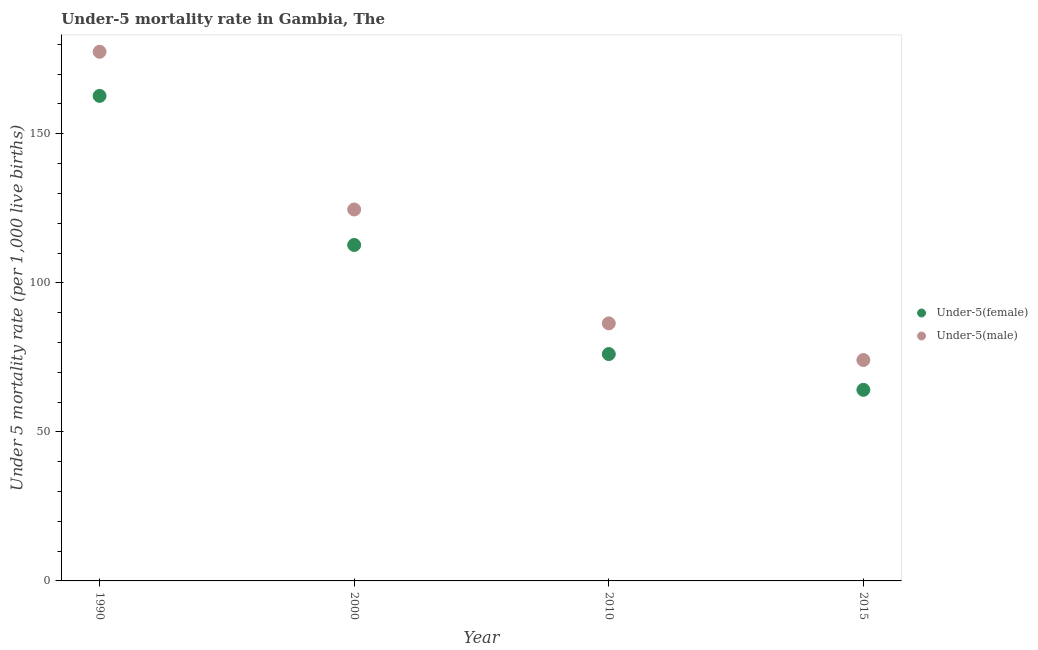Is the number of dotlines equal to the number of legend labels?
Your answer should be very brief. Yes. What is the under-5 male mortality rate in 2010?
Offer a very short reply. 86.4. Across all years, what is the maximum under-5 female mortality rate?
Offer a very short reply. 162.7. Across all years, what is the minimum under-5 male mortality rate?
Make the answer very short. 74.1. In which year was the under-5 female mortality rate maximum?
Provide a short and direct response. 1990. In which year was the under-5 male mortality rate minimum?
Give a very brief answer. 2015. What is the total under-5 female mortality rate in the graph?
Your answer should be compact. 415.6. What is the difference between the under-5 female mortality rate in 1990 and that in 2015?
Provide a short and direct response. 98.6. What is the average under-5 male mortality rate per year?
Offer a very short reply. 115.65. In the year 2010, what is the difference between the under-5 male mortality rate and under-5 female mortality rate?
Your response must be concise. 10.3. In how many years, is the under-5 male mortality rate greater than 30?
Your answer should be very brief. 4. What is the ratio of the under-5 female mortality rate in 2010 to that in 2015?
Your response must be concise. 1.19. Is the under-5 female mortality rate in 1990 less than that in 2010?
Make the answer very short. No. What is the difference between the highest and the second highest under-5 male mortality rate?
Offer a terse response. 52.9. What is the difference between the highest and the lowest under-5 male mortality rate?
Give a very brief answer. 103.4. In how many years, is the under-5 male mortality rate greater than the average under-5 male mortality rate taken over all years?
Provide a succinct answer. 2. Is the sum of the under-5 female mortality rate in 1990 and 2010 greater than the maximum under-5 male mortality rate across all years?
Your answer should be compact. Yes. Does the under-5 female mortality rate monotonically increase over the years?
Keep it short and to the point. No. How many dotlines are there?
Your answer should be very brief. 2. How many years are there in the graph?
Make the answer very short. 4. What is the difference between two consecutive major ticks on the Y-axis?
Offer a terse response. 50. Are the values on the major ticks of Y-axis written in scientific E-notation?
Offer a terse response. No. Does the graph contain any zero values?
Offer a terse response. No. How are the legend labels stacked?
Offer a terse response. Vertical. What is the title of the graph?
Offer a terse response. Under-5 mortality rate in Gambia, The. What is the label or title of the Y-axis?
Offer a very short reply. Under 5 mortality rate (per 1,0 live births). What is the Under 5 mortality rate (per 1,000 live births) in Under-5(female) in 1990?
Offer a terse response. 162.7. What is the Under 5 mortality rate (per 1,000 live births) of Under-5(male) in 1990?
Offer a terse response. 177.5. What is the Under 5 mortality rate (per 1,000 live births) in Under-5(female) in 2000?
Give a very brief answer. 112.7. What is the Under 5 mortality rate (per 1,000 live births) in Under-5(male) in 2000?
Your answer should be compact. 124.6. What is the Under 5 mortality rate (per 1,000 live births) of Under-5(female) in 2010?
Your answer should be very brief. 76.1. What is the Under 5 mortality rate (per 1,000 live births) in Under-5(male) in 2010?
Keep it short and to the point. 86.4. What is the Under 5 mortality rate (per 1,000 live births) in Under-5(female) in 2015?
Your answer should be compact. 64.1. What is the Under 5 mortality rate (per 1,000 live births) in Under-5(male) in 2015?
Make the answer very short. 74.1. Across all years, what is the maximum Under 5 mortality rate (per 1,000 live births) in Under-5(female)?
Offer a very short reply. 162.7. Across all years, what is the maximum Under 5 mortality rate (per 1,000 live births) of Under-5(male)?
Your answer should be compact. 177.5. Across all years, what is the minimum Under 5 mortality rate (per 1,000 live births) in Under-5(female)?
Provide a short and direct response. 64.1. Across all years, what is the minimum Under 5 mortality rate (per 1,000 live births) in Under-5(male)?
Your answer should be very brief. 74.1. What is the total Under 5 mortality rate (per 1,000 live births) of Under-5(female) in the graph?
Your answer should be very brief. 415.6. What is the total Under 5 mortality rate (per 1,000 live births) of Under-5(male) in the graph?
Ensure brevity in your answer.  462.6. What is the difference between the Under 5 mortality rate (per 1,000 live births) in Under-5(female) in 1990 and that in 2000?
Keep it short and to the point. 50. What is the difference between the Under 5 mortality rate (per 1,000 live births) of Under-5(male) in 1990 and that in 2000?
Offer a terse response. 52.9. What is the difference between the Under 5 mortality rate (per 1,000 live births) in Under-5(female) in 1990 and that in 2010?
Your answer should be very brief. 86.6. What is the difference between the Under 5 mortality rate (per 1,000 live births) in Under-5(male) in 1990 and that in 2010?
Provide a succinct answer. 91.1. What is the difference between the Under 5 mortality rate (per 1,000 live births) in Under-5(female) in 1990 and that in 2015?
Provide a succinct answer. 98.6. What is the difference between the Under 5 mortality rate (per 1,000 live births) in Under-5(male) in 1990 and that in 2015?
Provide a succinct answer. 103.4. What is the difference between the Under 5 mortality rate (per 1,000 live births) of Under-5(female) in 2000 and that in 2010?
Offer a terse response. 36.6. What is the difference between the Under 5 mortality rate (per 1,000 live births) of Under-5(male) in 2000 and that in 2010?
Make the answer very short. 38.2. What is the difference between the Under 5 mortality rate (per 1,000 live births) of Under-5(female) in 2000 and that in 2015?
Give a very brief answer. 48.6. What is the difference between the Under 5 mortality rate (per 1,000 live births) of Under-5(male) in 2000 and that in 2015?
Provide a short and direct response. 50.5. What is the difference between the Under 5 mortality rate (per 1,000 live births) of Under-5(female) in 2010 and that in 2015?
Provide a short and direct response. 12. What is the difference between the Under 5 mortality rate (per 1,000 live births) in Under-5(male) in 2010 and that in 2015?
Offer a very short reply. 12.3. What is the difference between the Under 5 mortality rate (per 1,000 live births) of Under-5(female) in 1990 and the Under 5 mortality rate (per 1,000 live births) of Under-5(male) in 2000?
Offer a very short reply. 38.1. What is the difference between the Under 5 mortality rate (per 1,000 live births) of Under-5(female) in 1990 and the Under 5 mortality rate (per 1,000 live births) of Under-5(male) in 2010?
Your response must be concise. 76.3. What is the difference between the Under 5 mortality rate (per 1,000 live births) of Under-5(female) in 1990 and the Under 5 mortality rate (per 1,000 live births) of Under-5(male) in 2015?
Provide a succinct answer. 88.6. What is the difference between the Under 5 mortality rate (per 1,000 live births) in Under-5(female) in 2000 and the Under 5 mortality rate (per 1,000 live births) in Under-5(male) in 2010?
Offer a terse response. 26.3. What is the difference between the Under 5 mortality rate (per 1,000 live births) in Under-5(female) in 2000 and the Under 5 mortality rate (per 1,000 live births) in Under-5(male) in 2015?
Keep it short and to the point. 38.6. What is the average Under 5 mortality rate (per 1,000 live births) in Under-5(female) per year?
Keep it short and to the point. 103.9. What is the average Under 5 mortality rate (per 1,000 live births) of Under-5(male) per year?
Ensure brevity in your answer.  115.65. In the year 1990, what is the difference between the Under 5 mortality rate (per 1,000 live births) of Under-5(female) and Under 5 mortality rate (per 1,000 live births) of Under-5(male)?
Your answer should be compact. -14.8. In the year 2000, what is the difference between the Under 5 mortality rate (per 1,000 live births) of Under-5(female) and Under 5 mortality rate (per 1,000 live births) of Under-5(male)?
Your answer should be very brief. -11.9. In the year 2010, what is the difference between the Under 5 mortality rate (per 1,000 live births) of Under-5(female) and Under 5 mortality rate (per 1,000 live births) of Under-5(male)?
Your response must be concise. -10.3. In the year 2015, what is the difference between the Under 5 mortality rate (per 1,000 live births) in Under-5(female) and Under 5 mortality rate (per 1,000 live births) in Under-5(male)?
Your answer should be very brief. -10. What is the ratio of the Under 5 mortality rate (per 1,000 live births) of Under-5(female) in 1990 to that in 2000?
Provide a short and direct response. 1.44. What is the ratio of the Under 5 mortality rate (per 1,000 live births) of Under-5(male) in 1990 to that in 2000?
Your answer should be very brief. 1.42. What is the ratio of the Under 5 mortality rate (per 1,000 live births) of Under-5(female) in 1990 to that in 2010?
Offer a very short reply. 2.14. What is the ratio of the Under 5 mortality rate (per 1,000 live births) in Under-5(male) in 1990 to that in 2010?
Make the answer very short. 2.05. What is the ratio of the Under 5 mortality rate (per 1,000 live births) of Under-5(female) in 1990 to that in 2015?
Ensure brevity in your answer.  2.54. What is the ratio of the Under 5 mortality rate (per 1,000 live births) of Under-5(male) in 1990 to that in 2015?
Provide a short and direct response. 2.4. What is the ratio of the Under 5 mortality rate (per 1,000 live births) of Under-5(female) in 2000 to that in 2010?
Provide a short and direct response. 1.48. What is the ratio of the Under 5 mortality rate (per 1,000 live births) in Under-5(male) in 2000 to that in 2010?
Offer a terse response. 1.44. What is the ratio of the Under 5 mortality rate (per 1,000 live births) of Under-5(female) in 2000 to that in 2015?
Provide a short and direct response. 1.76. What is the ratio of the Under 5 mortality rate (per 1,000 live births) of Under-5(male) in 2000 to that in 2015?
Make the answer very short. 1.68. What is the ratio of the Under 5 mortality rate (per 1,000 live births) in Under-5(female) in 2010 to that in 2015?
Offer a terse response. 1.19. What is the ratio of the Under 5 mortality rate (per 1,000 live births) of Under-5(male) in 2010 to that in 2015?
Make the answer very short. 1.17. What is the difference between the highest and the second highest Under 5 mortality rate (per 1,000 live births) in Under-5(male)?
Make the answer very short. 52.9. What is the difference between the highest and the lowest Under 5 mortality rate (per 1,000 live births) of Under-5(female)?
Your answer should be very brief. 98.6. What is the difference between the highest and the lowest Under 5 mortality rate (per 1,000 live births) in Under-5(male)?
Keep it short and to the point. 103.4. 